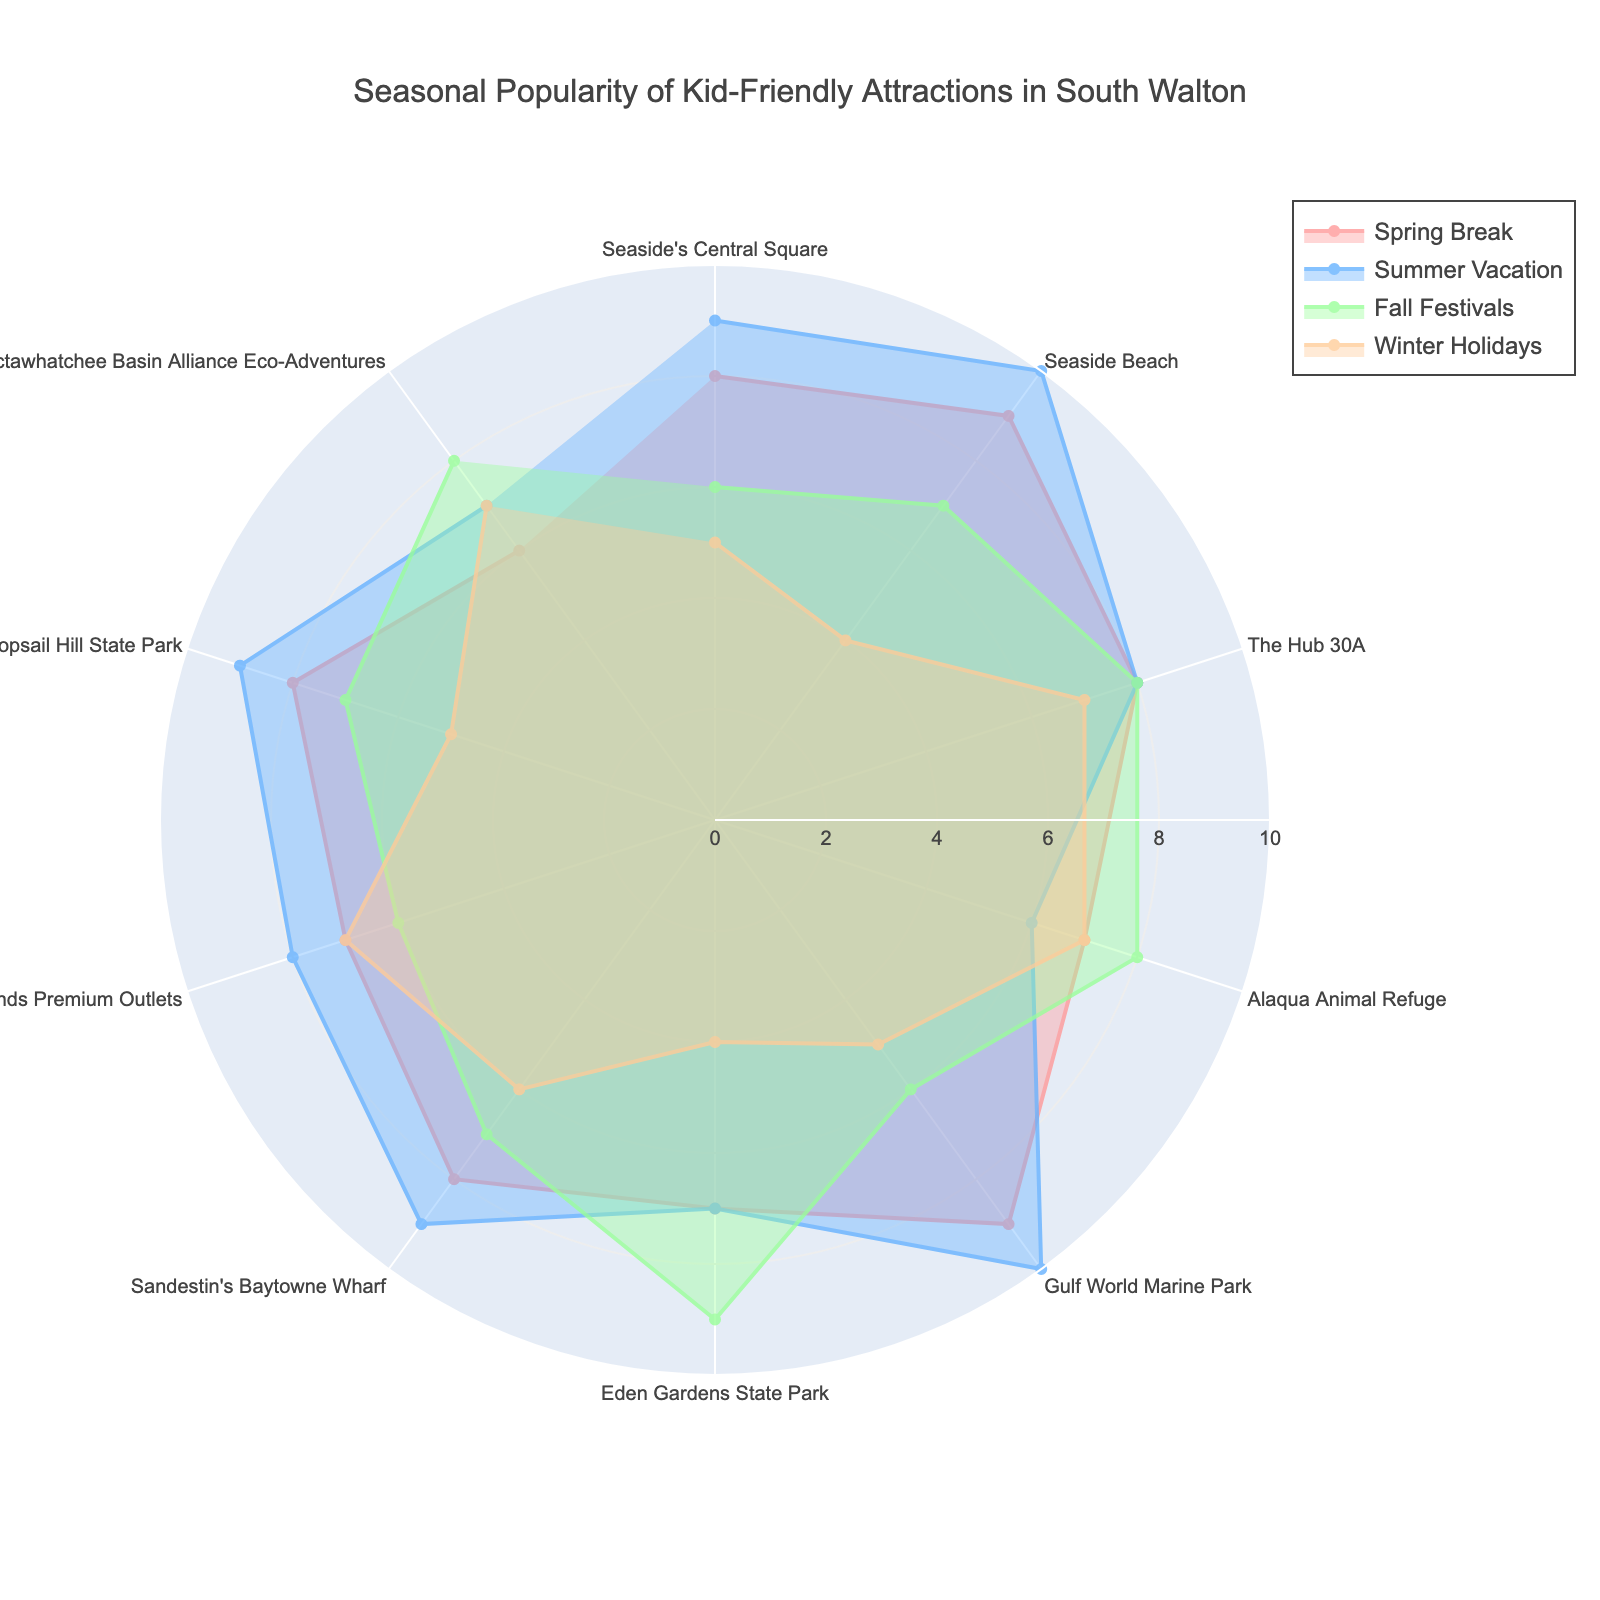Which season has the highest popularity for Seaside Beach? To determine the highest popularity for Seaside Beach, locate Seaside Beach on the radar chart and compare the values across each season. Summer Vacation has the highest value at 10.
Answer: Summer Vacation What is the average popularity of Alaqua Animal Refuge across all seasons? Add the popularity values for Alaqua Animal Refuge across all seasons (7 + 6 + 8 + 7) and divide by the number of seasons (4). The sum is 28, so the average is 28 / 4 = 7.
Answer: 7 Which activity has the same popularity score in every season? Look for an activity where all the values in each season are equal. The Hub 30A has a consistent score of 8 in all seasons.
Answer: The Hub 30A How does Eden Gardens State Park's popularity in Fall Festivals compare to its popularity in Winter Holidays? Compare the values of Eden Gardens State Park in Fall Festivals (9) and Winter Holidays (4). The difference is 9 - 4 = 5, meaning it's more popular in Fall Festivals.
Answer: More popular in Fall Festivals Which seasons have the maximum popularity for Gulf World Marine Park, and are these values the same? Identify the highest value for Gulf World Marine Park across all seasons. Spring Break and Summer Vacation both have the highest value of 10.
Answer: Spring Break, Summer Vacation (Same) Compare the popularity of Seaside's Central Square and Topsail Hill State Park during Summer Vacation. Which is more popular? Compare the values of Seaside's Central Square (9) and Topsail Hill State Park (9) during Summer Vacation. Both have the same popularity.
Answer: Same What is the overall range in popularity for Silver Sands Premium Outlets from the lowest to the highest across seasons? Identify the lowest (6 in Spring Break and Fall Festivals) and highest (8 in Summer Vacation) values for Silver Sands Premium Outlets. The range is 8 - 6 = 2.
Answer: 2 What is the difference in popularity for Choctawhatchee Basin Alliance Eco-Adventures between Spring Break and Fall Festivals? Compare the values in Spring Break (6) and Fall Festivals (8). The difference is 8 - 6 = 2.
Answer: 2 Which activity sees the largest drop in popularity from Summer Vacation to Winter Holidays? Examine the values for each activity between Summer Vacation and Winter Holidays to find the largest drop. Seaside Beach drops from 10 to 4, a decrease of 6 points which is the largest drop.
Answer: Seaside Beach During which season does Sandestin's Baytowne Wharf have its highest popularity? Locate Sandestin's Baytowne Wharf on the radar chart and compare the values across each season. The highest value is during Summer Vacation at 9.
Answer: Summer Vacation 